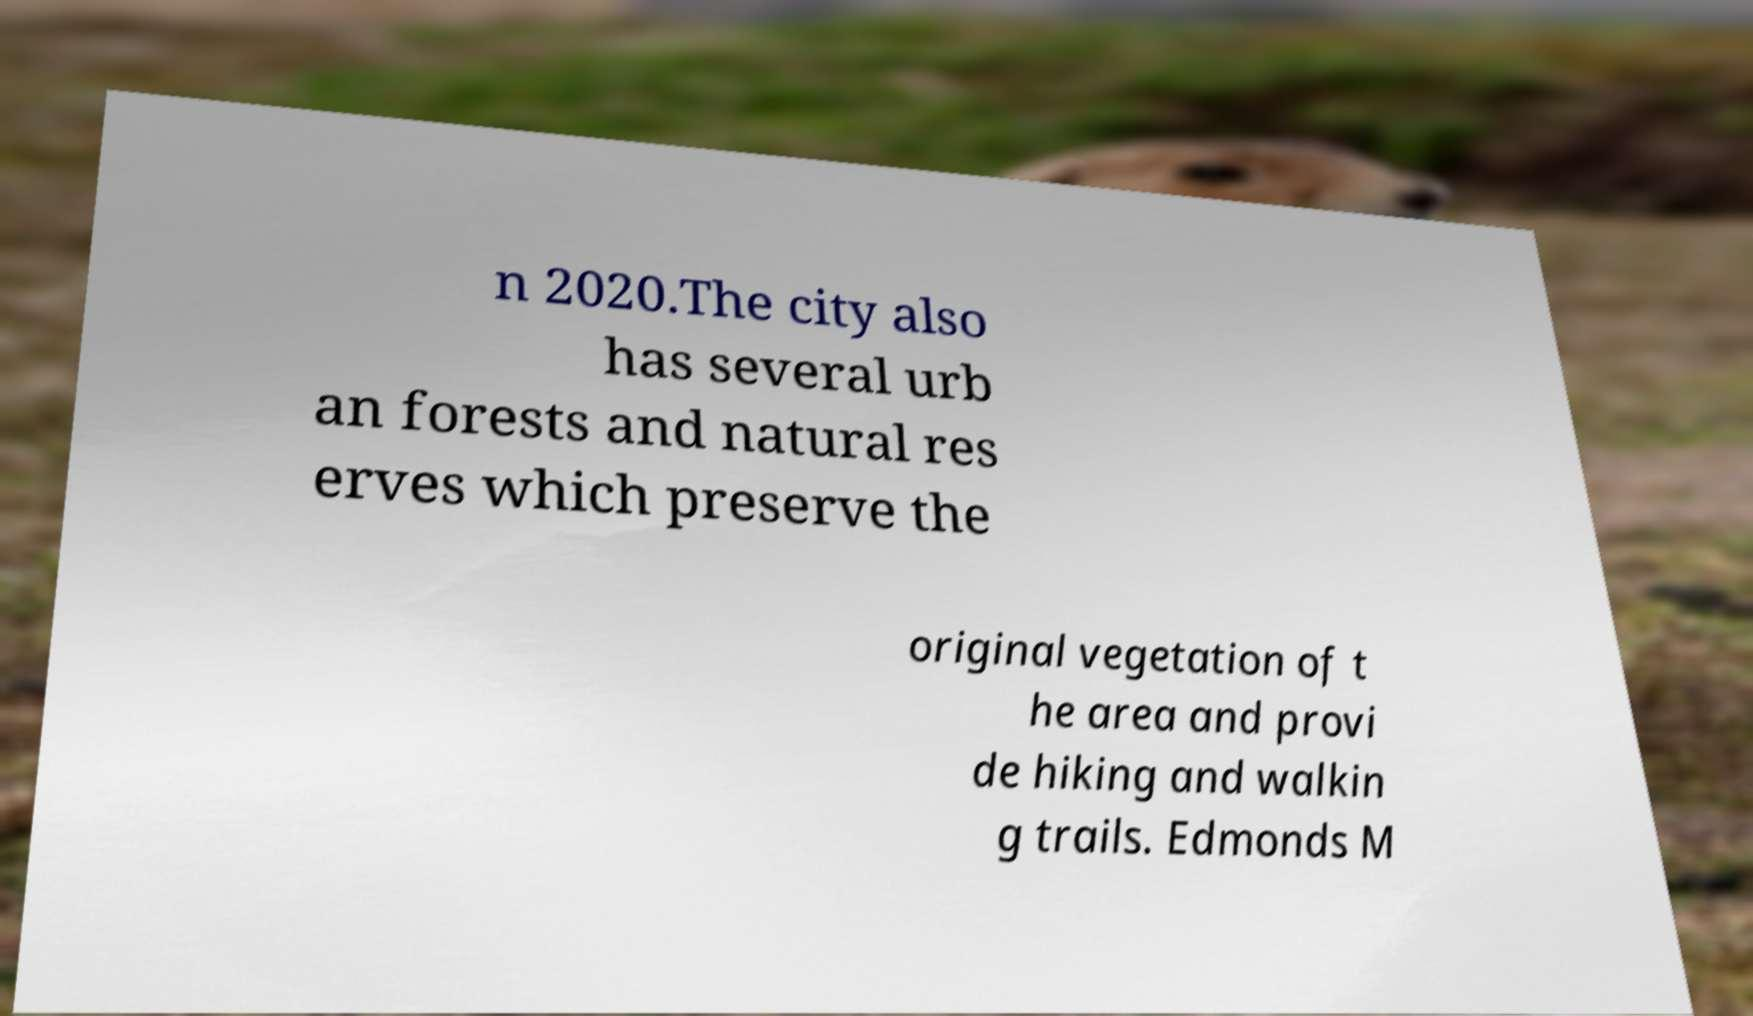Could you assist in decoding the text presented in this image and type it out clearly? n 2020.The city also has several urb an forests and natural res erves which preserve the original vegetation of t he area and provi de hiking and walkin g trails. Edmonds M 